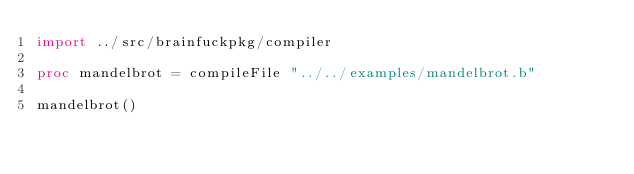<code> <loc_0><loc_0><loc_500><loc_500><_Nim_>import ../src/brainfuckpkg/compiler

proc mandelbrot = compileFile "../../examples/mandelbrot.b"

mandelbrot()
</code> 